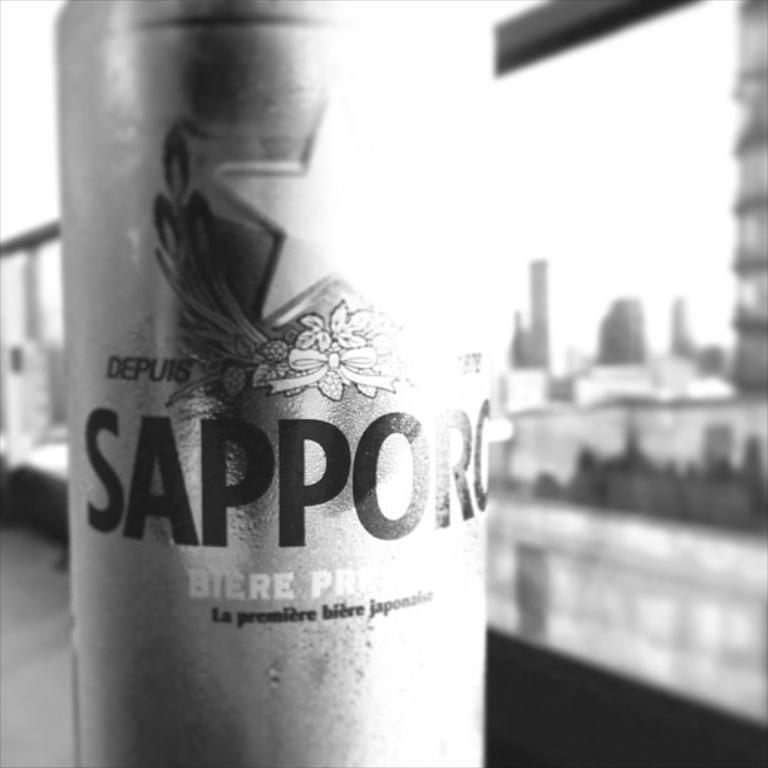<image>
Create a compact narrative representing the image presented. A black and white picture of a can of sapporo beer is set against the cityscape 